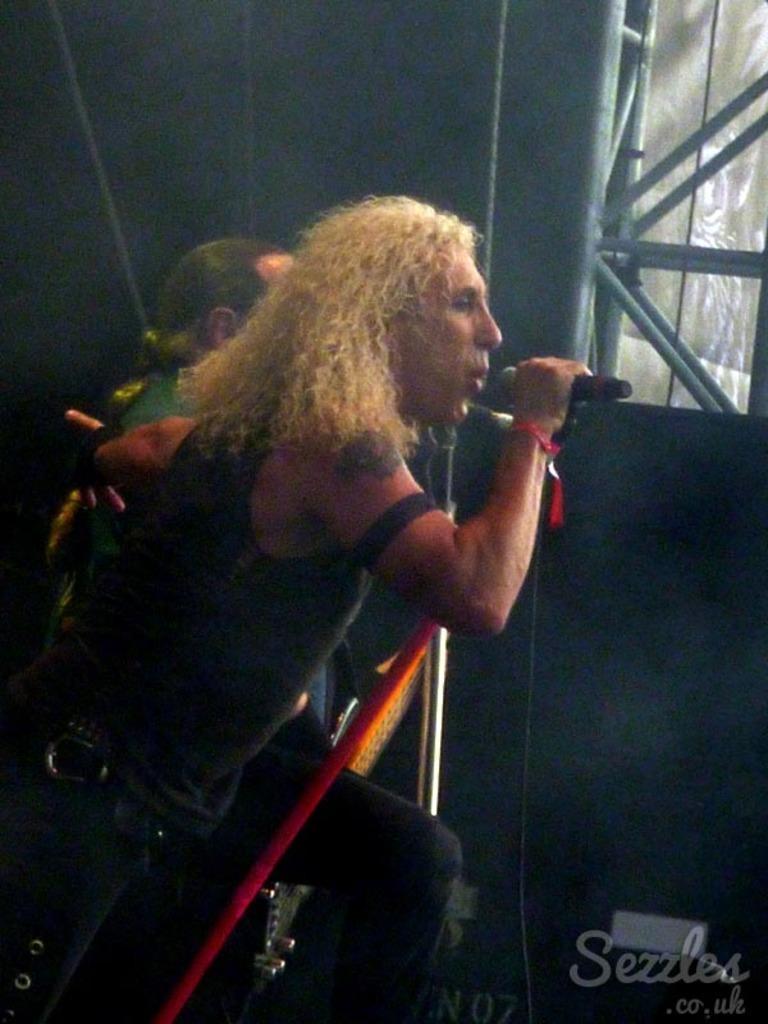Describe this image in one or two sentences. In this picture we can see two people, mic, guitar, rods, screen and in the background it is dark and at the bottom right corner we can see some text. 